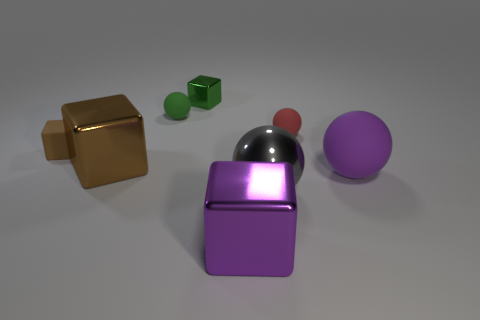Add 1 small green metallic objects. How many objects exist? 9 Subtract all metal spheres. How many spheres are left? 3 Subtract 1 blocks. How many blocks are left? 3 Subtract all red spheres. How many spheres are left? 3 Subtract all purple cylinders. How many red spheres are left? 1 Subtract all brown blocks. Subtract all green cylinders. How many blocks are left? 2 Subtract all small brown matte cubes. Subtract all balls. How many objects are left? 3 Add 7 metallic balls. How many metallic balls are left? 8 Add 5 brown rubber cubes. How many brown rubber cubes exist? 6 Subtract 0 cyan balls. How many objects are left? 8 